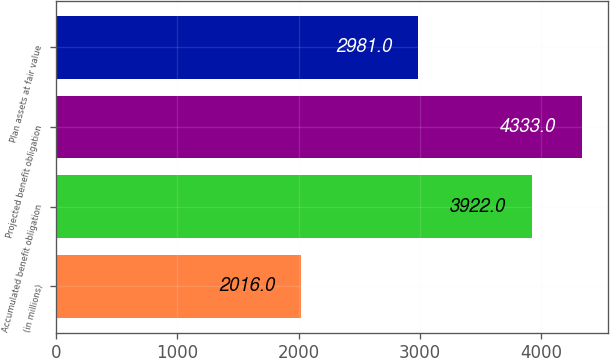<chart> <loc_0><loc_0><loc_500><loc_500><bar_chart><fcel>(in millions)<fcel>Accumulated benefit obligation<fcel>Projected benefit obligation<fcel>Plan assets at fair value<nl><fcel>2016<fcel>3922<fcel>4333<fcel>2981<nl></chart> 